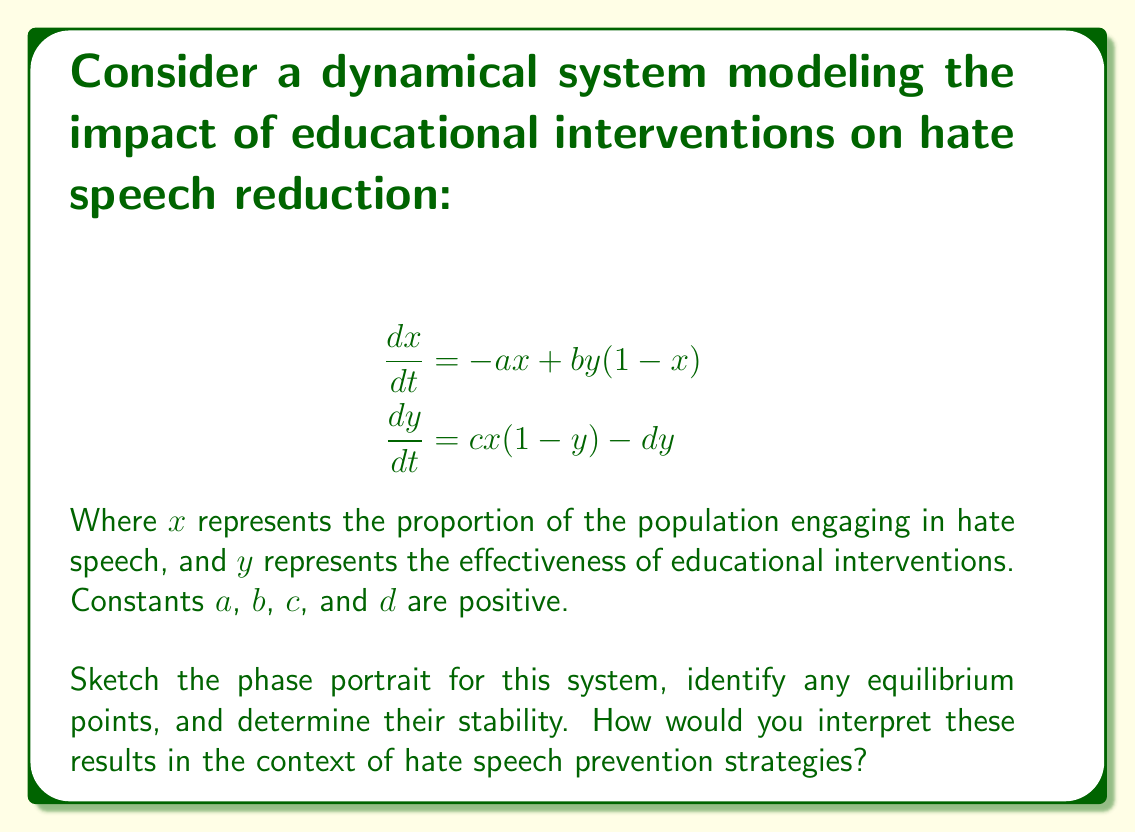Can you answer this question? 1. Find equilibrium points:
   Set $\frac{dx}{dt} = 0$ and $\frac{dy}{dt} = 0$
   
   $$-ax + by(1-x) = 0$$
   $$cx(1-y) - dy = 0$$

   Solving these equations, we get three equilibrium points:
   $(0,0)$, $(1,1)$, and $(\frac{d}{c+d}, \frac{a}{a+b})$

2. Analyze stability:
   Compute the Jacobian matrix:
   
   $$J = \begin{bmatrix}
   -a-by & b(1-x) \\
   c(1-y) & -cx-d
   \end{bmatrix}$$

   Evaluate at each equilibrium point:
   
   At $(0,0)$: $J_{(0,0)} = \begin{bmatrix} -a & b \\ c & -d \end{bmatrix}$
   Eigenvalues: $\lambda_1 < 0, \lambda_2 < 0$ (stable node)
   
   At $(1,1)$: $J_{(1,1)} = \begin{bmatrix} -a-b & 0 \\ 0 & -c-d \end{bmatrix}$
   Eigenvalues: $\lambda_1 = -a-b < 0, \lambda_2 = -c-d < 0$ (stable node)
   
   At $(\frac{d}{c+d}, \frac{a}{a+b})$: Eigenvalues have negative real parts (stable focus or node)

3. Sketch phase portrait:
   
[asy]
import graph;
size(200);
xaxis("x", 0, 1, Arrow);
yaxis("y", 0, 1, Arrow);

real a = 0.5, b = 0.3, c = 0.4, d = 0.2;

pair F(pair z) {
  real x = z.x, y = z.y;
  return (-a*x + b*y*(1-x), c*x*(1-y) - d*y);
}

add(vectorfield(F, (0,0), (1,1), 15, 0.03, blue));

dot((0,0));
dot((1,1));
dot((d/(c+d), a/(a+b)));

label("(0,0)", (0,0), SW);
label("(1,1)", (1,1), NE);
label("(d/(c+d), a/(a+b))", (d/(c+d), a/(a+b)), SE);
[/asy]

4. Interpretation:
   - $(0,0)$: No hate speech, no interventions needed (ideal but unstable)
   - $(1,1)$: Maximum hate speech despite maximum intervention (undesirable but stable)
   - $(\frac{d}{c+d}, \frac{a}{a+b})$: Balanced state where interventions effectively reduce hate speech (stable equilibrium)

The phase portrait suggests that educational interventions can effectively reduce hate speech, but continuous effort is needed to maintain the balanced state and prevent regression to higher levels of hate speech.
Answer: Three equilibrium points: $(0,0)$, $(1,1)$, $(\frac{d}{c+d}, \frac{a}{a+b})$. $(0,0)$ and $(1,1)$ are stable nodes; $(\frac{d}{c+d}, \frac{a}{a+b})$ is a stable focus or node. Continuous educational interventions are necessary to maintain reduced hate speech levels. 